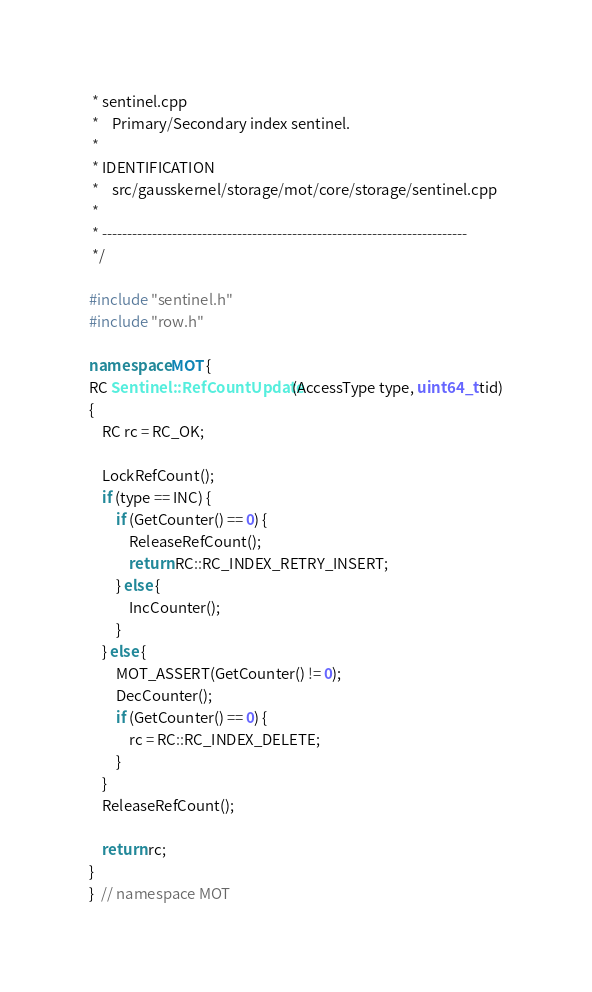<code> <loc_0><loc_0><loc_500><loc_500><_C++_> * sentinel.cpp
 *    Primary/Secondary index sentinel.
 *
 * IDENTIFICATION
 *    src/gausskernel/storage/mot/core/storage/sentinel.cpp
 *
 * -------------------------------------------------------------------------
 */

#include "sentinel.h"
#include "row.h"

namespace MOT {
RC Sentinel::RefCountUpdate(AccessType type, uint64_t tid)
{
    RC rc = RC_OK;

    LockRefCount();
    if (type == INC) {
        if (GetCounter() == 0) {
            ReleaseRefCount();
            return RC::RC_INDEX_RETRY_INSERT;
        } else {
            IncCounter();
        }
    } else {
        MOT_ASSERT(GetCounter() != 0);
        DecCounter();
        if (GetCounter() == 0) {
            rc = RC::RC_INDEX_DELETE;
        }
    }
    ReleaseRefCount();

    return rc;
}
}  // namespace MOT
</code> 